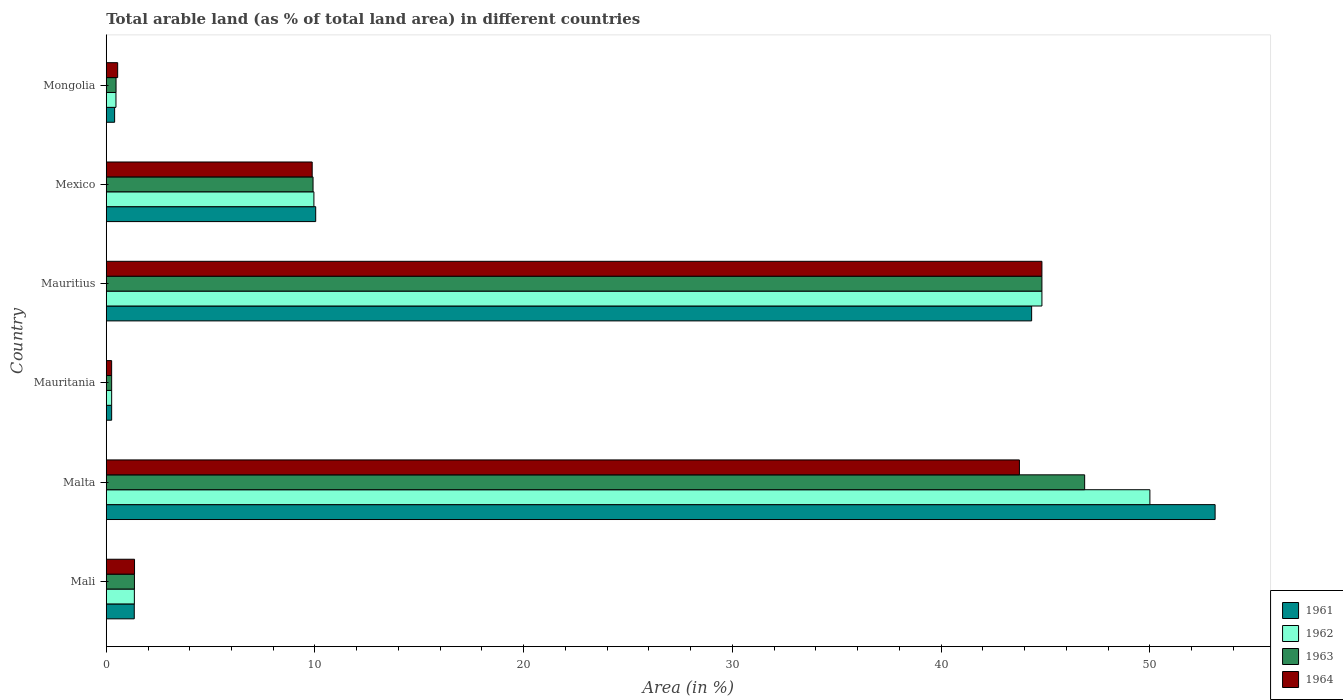How many different coloured bars are there?
Provide a short and direct response. 4. How many groups of bars are there?
Ensure brevity in your answer.  6. Are the number of bars on each tick of the Y-axis equal?
Your answer should be compact. Yes. What is the label of the 4th group of bars from the top?
Ensure brevity in your answer.  Mauritania. In how many cases, is the number of bars for a given country not equal to the number of legend labels?
Ensure brevity in your answer.  0. What is the percentage of arable land in 1963 in Mauritania?
Offer a terse response. 0.26. Across all countries, what is the maximum percentage of arable land in 1964?
Your response must be concise. 44.83. Across all countries, what is the minimum percentage of arable land in 1963?
Your answer should be very brief. 0.26. In which country was the percentage of arable land in 1962 maximum?
Ensure brevity in your answer.  Malta. In which country was the percentage of arable land in 1964 minimum?
Make the answer very short. Mauritania. What is the total percentage of arable land in 1961 in the graph?
Make the answer very short. 109.5. What is the difference between the percentage of arable land in 1962 in Mali and that in Mauritania?
Ensure brevity in your answer.  1.09. What is the difference between the percentage of arable land in 1961 in Mauritius and the percentage of arable land in 1963 in Mexico?
Offer a very short reply. 34.43. What is the average percentage of arable land in 1961 per country?
Keep it short and to the point. 18.25. What is the difference between the percentage of arable land in 1962 and percentage of arable land in 1963 in Mongolia?
Ensure brevity in your answer.  -0. What is the ratio of the percentage of arable land in 1964 in Mauritania to that in Mexico?
Provide a short and direct response. 0.03. Is the percentage of arable land in 1964 in Mali less than that in Mauritania?
Offer a very short reply. No. Is the difference between the percentage of arable land in 1962 in Malta and Mexico greater than the difference between the percentage of arable land in 1963 in Malta and Mexico?
Provide a short and direct response. Yes. What is the difference between the highest and the second highest percentage of arable land in 1964?
Your answer should be very brief. 1.08. What is the difference between the highest and the lowest percentage of arable land in 1964?
Provide a short and direct response. 44.57. Is it the case that in every country, the sum of the percentage of arable land in 1962 and percentage of arable land in 1961 is greater than the sum of percentage of arable land in 1963 and percentage of arable land in 1964?
Keep it short and to the point. No. What does the 1st bar from the top in Mauritania represents?
Your response must be concise. 1964. How many countries are there in the graph?
Provide a succinct answer. 6. What is the difference between two consecutive major ticks on the X-axis?
Ensure brevity in your answer.  10. Are the values on the major ticks of X-axis written in scientific E-notation?
Your answer should be compact. No. Does the graph contain any zero values?
Offer a very short reply. No. Does the graph contain grids?
Keep it short and to the point. No. How many legend labels are there?
Ensure brevity in your answer.  4. How are the legend labels stacked?
Offer a terse response. Vertical. What is the title of the graph?
Give a very brief answer. Total arable land (as % of total land area) in different countries. What is the label or title of the X-axis?
Your response must be concise. Area (in %). What is the label or title of the Y-axis?
Give a very brief answer. Country. What is the Area (in %) of 1961 in Mali?
Your answer should be very brief. 1.34. What is the Area (in %) of 1962 in Mali?
Your response must be concise. 1.35. What is the Area (in %) of 1963 in Mali?
Make the answer very short. 1.35. What is the Area (in %) of 1964 in Mali?
Give a very brief answer. 1.35. What is the Area (in %) of 1961 in Malta?
Keep it short and to the point. 53.12. What is the Area (in %) of 1963 in Malta?
Offer a very short reply. 46.88. What is the Area (in %) of 1964 in Malta?
Keep it short and to the point. 43.75. What is the Area (in %) in 1961 in Mauritania?
Offer a terse response. 0.26. What is the Area (in %) in 1962 in Mauritania?
Make the answer very short. 0.26. What is the Area (in %) in 1963 in Mauritania?
Your answer should be compact. 0.26. What is the Area (in %) of 1964 in Mauritania?
Offer a very short reply. 0.26. What is the Area (in %) of 1961 in Mauritius?
Offer a terse response. 44.33. What is the Area (in %) of 1962 in Mauritius?
Provide a short and direct response. 44.83. What is the Area (in %) of 1963 in Mauritius?
Ensure brevity in your answer.  44.83. What is the Area (in %) in 1964 in Mauritius?
Keep it short and to the point. 44.83. What is the Area (in %) of 1961 in Mexico?
Your answer should be compact. 10.03. What is the Area (in %) of 1962 in Mexico?
Your answer should be compact. 9.95. What is the Area (in %) in 1963 in Mexico?
Offer a terse response. 9.91. What is the Area (in %) in 1964 in Mexico?
Provide a succinct answer. 9.87. What is the Area (in %) in 1961 in Mongolia?
Keep it short and to the point. 0.4. What is the Area (in %) in 1962 in Mongolia?
Provide a succinct answer. 0.47. What is the Area (in %) of 1963 in Mongolia?
Make the answer very short. 0.47. What is the Area (in %) in 1964 in Mongolia?
Your response must be concise. 0.55. Across all countries, what is the maximum Area (in %) in 1961?
Ensure brevity in your answer.  53.12. Across all countries, what is the maximum Area (in %) of 1962?
Your answer should be compact. 50. Across all countries, what is the maximum Area (in %) in 1963?
Provide a succinct answer. 46.88. Across all countries, what is the maximum Area (in %) of 1964?
Ensure brevity in your answer.  44.83. Across all countries, what is the minimum Area (in %) of 1961?
Make the answer very short. 0.26. Across all countries, what is the minimum Area (in %) in 1962?
Give a very brief answer. 0.26. Across all countries, what is the minimum Area (in %) in 1963?
Provide a succinct answer. 0.26. Across all countries, what is the minimum Area (in %) in 1964?
Offer a terse response. 0.26. What is the total Area (in %) in 1961 in the graph?
Give a very brief answer. 109.5. What is the total Area (in %) in 1962 in the graph?
Ensure brevity in your answer.  106.85. What is the total Area (in %) in 1963 in the graph?
Provide a short and direct response. 103.69. What is the total Area (in %) in 1964 in the graph?
Provide a short and direct response. 100.6. What is the difference between the Area (in %) of 1961 in Mali and that in Malta?
Provide a short and direct response. -51.78. What is the difference between the Area (in %) of 1962 in Mali and that in Malta?
Provide a short and direct response. -48.65. What is the difference between the Area (in %) of 1963 in Mali and that in Malta?
Offer a terse response. -45.52. What is the difference between the Area (in %) in 1964 in Mali and that in Malta?
Your answer should be very brief. -42.4. What is the difference between the Area (in %) in 1961 in Mali and that in Mauritania?
Give a very brief answer. 1.08. What is the difference between the Area (in %) in 1962 in Mali and that in Mauritania?
Your response must be concise. 1.09. What is the difference between the Area (in %) of 1963 in Mali and that in Mauritania?
Give a very brief answer. 1.09. What is the difference between the Area (in %) of 1964 in Mali and that in Mauritania?
Ensure brevity in your answer.  1.1. What is the difference between the Area (in %) of 1961 in Mali and that in Mauritius?
Keep it short and to the point. -42.99. What is the difference between the Area (in %) in 1962 in Mali and that in Mauritius?
Make the answer very short. -43.48. What is the difference between the Area (in %) of 1963 in Mali and that in Mauritius?
Your response must be concise. -43.48. What is the difference between the Area (in %) in 1964 in Mali and that in Mauritius?
Your answer should be very brief. -43.47. What is the difference between the Area (in %) of 1961 in Mali and that in Mexico?
Ensure brevity in your answer.  -8.69. What is the difference between the Area (in %) in 1962 in Mali and that in Mexico?
Keep it short and to the point. -8.6. What is the difference between the Area (in %) of 1963 in Mali and that in Mexico?
Your answer should be very brief. -8.56. What is the difference between the Area (in %) in 1964 in Mali and that in Mexico?
Provide a short and direct response. -8.51. What is the difference between the Area (in %) of 1961 in Mali and that in Mongolia?
Your answer should be very brief. 0.94. What is the difference between the Area (in %) in 1962 in Mali and that in Mongolia?
Your answer should be compact. 0.88. What is the difference between the Area (in %) of 1963 in Mali and that in Mongolia?
Give a very brief answer. 0.88. What is the difference between the Area (in %) of 1964 in Mali and that in Mongolia?
Ensure brevity in your answer.  0.81. What is the difference between the Area (in %) of 1961 in Malta and that in Mauritania?
Offer a very short reply. 52.87. What is the difference between the Area (in %) of 1962 in Malta and that in Mauritania?
Your answer should be compact. 49.74. What is the difference between the Area (in %) of 1963 in Malta and that in Mauritania?
Your answer should be very brief. 46.62. What is the difference between the Area (in %) of 1964 in Malta and that in Mauritania?
Your answer should be very brief. 43.49. What is the difference between the Area (in %) in 1961 in Malta and that in Mauritius?
Make the answer very short. 8.79. What is the difference between the Area (in %) of 1962 in Malta and that in Mauritius?
Your answer should be very brief. 5.17. What is the difference between the Area (in %) of 1963 in Malta and that in Mauritius?
Ensure brevity in your answer.  2.05. What is the difference between the Area (in %) in 1964 in Malta and that in Mauritius?
Give a very brief answer. -1.08. What is the difference between the Area (in %) in 1961 in Malta and that in Mexico?
Offer a very short reply. 43.09. What is the difference between the Area (in %) of 1962 in Malta and that in Mexico?
Provide a short and direct response. 40.05. What is the difference between the Area (in %) in 1963 in Malta and that in Mexico?
Make the answer very short. 36.97. What is the difference between the Area (in %) of 1964 in Malta and that in Mexico?
Your answer should be compact. 33.88. What is the difference between the Area (in %) of 1961 in Malta and that in Mongolia?
Ensure brevity in your answer.  52.72. What is the difference between the Area (in %) of 1962 in Malta and that in Mongolia?
Provide a short and direct response. 49.53. What is the difference between the Area (in %) in 1963 in Malta and that in Mongolia?
Make the answer very short. 46.41. What is the difference between the Area (in %) of 1964 in Malta and that in Mongolia?
Provide a succinct answer. 43.2. What is the difference between the Area (in %) in 1961 in Mauritania and that in Mauritius?
Your answer should be very brief. -44.08. What is the difference between the Area (in %) of 1962 in Mauritania and that in Mauritius?
Your answer should be very brief. -44.57. What is the difference between the Area (in %) of 1963 in Mauritania and that in Mauritius?
Your response must be concise. -44.57. What is the difference between the Area (in %) of 1964 in Mauritania and that in Mauritius?
Provide a succinct answer. -44.57. What is the difference between the Area (in %) of 1961 in Mauritania and that in Mexico?
Your answer should be very brief. -9.78. What is the difference between the Area (in %) of 1962 in Mauritania and that in Mexico?
Provide a succinct answer. -9.69. What is the difference between the Area (in %) in 1963 in Mauritania and that in Mexico?
Ensure brevity in your answer.  -9.65. What is the difference between the Area (in %) in 1964 in Mauritania and that in Mexico?
Keep it short and to the point. -9.61. What is the difference between the Area (in %) of 1961 in Mauritania and that in Mongolia?
Offer a terse response. -0.14. What is the difference between the Area (in %) in 1962 in Mauritania and that in Mongolia?
Provide a short and direct response. -0.21. What is the difference between the Area (in %) in 1963 in Mauritania and that in Mongolia?
Your response must be concise. -0.21. What is the difference between the Area (in %) of 1964 in Mauritania and that in Mongolia?
Ensure brevity in your answer.  -0.29. What is the difference between the Area (in %) in 1961 in Mauritius and that in Mexico?
Give a very brief answer. 34.3. What is the difference between the Area (in %) in 1962 in Mauritius and that in Mexico?
Your answer should be compact. 34.88. What is the difference between the Area (in %) in 1963 in Mauritius and that in Mexico?
Your answer should be very brief. 34.92. What is the difference between the Area (in %) in 1964 in Mauritius and that in Mexico?
Offer a terse response. 34.96. What is the difference between the Area (in %) of 1961 in Mauritius and that in Mongolia?
Your response must be concise. 43.93. What is the difference between the Area (in %) in 1962 in Mauritius and that in Mongolia?
Make the answer very short. 44.36. What is the difference between the Area (in %) of 1963 in Mauritius and that in Mongolia?
Offer a terse response. 44.36. What is the difference between the Area (in %) in 1964 in Mauritius and that in Mongolia?
Provide a succinct answer. 44.28. What is the difference between the Area (in %) of 1961 in Mexico and that in Mongolia?
Your answer should be very brief. 9.63. What is the difference between the Area (in %) of 1962 in Mexico and that in Mongolia?
Provide a succinct answer. 9.48. What is the difference between the Area (in %) in 1963 in Mexico and that in Mongolia?
Offer a very short reply. 9.44. What is the difference between the Area (in %) of 1964 in Mexico and that in Mongolia?
Keep it short and to the point. 9.32. What is the difference between the Area (in %) of 1961 in Mali and the Area (in %) of 1962 in Malta?
Offer a very short reply. -48.66. What is the difference between the Area (in %) of 1961 in Mali and the Area (in %) of 1963 in Malta?
Your answer should be compact. -45.53. What is the difference between the Area (in %) of 1961 in Mali and the Area (in %) of 1964 in Malta?
Provide a succinct answer. -42.41. What is the difference between the Area (in %) of 1962 in Mali and the Area (in %) of 1963 in Malta?
Offer a very short reply. -45.53. What is the difference between the Area (in %) of 1962 in Mali and the Area (in %) of 1964 in Malta?
Your answer should be very brief. -42.4. What is the difference between the Area (in %) of 1963 in Mali and the Area (in %) of 1964 in Malta?
Offer a terse response. -42.4. What is the difference between the Area (in %) of 1961 in Mali and the Area (in %) of 1962 in Mauritania?
Provide a succinct answer. 1.08. What is the difference between the Area (in %) of 1961 in Mali and the Area (in %) of 1963 in Mauritania?
Offer a terse response. 1.08. What is the difference between the Area (in %) of 1961 in Mali and the Area (in %) of 1964 in Mauritania?
Give a very brief answer. 1.08. What is the difference between the Area (in %) of 1962 in Mali and the Area (in %) of 1963 in Mauritania?
Offer a terse response. 1.09. What is the difference between the Area (in %) in 1962 in Mali and the Area (in %) in 1964 in Mauritania?
Give a very brief answer. 1.09. What is the difference between the Area (in %) of 1963 in Mali and the Area (in %) of 1964 in Mauritania?
Offer a very short reply. 1.09. What is the difference between the Area (in %) of 1961 in Mali and the Area (in %) of 1962 in Mauritius?
Keep it short and to the point. -43.49. What is the difference between the Area (in %) of 1961 in Mali and the Area (in %) of 1963 in Mauritius?
Offer a terse response. -43.49. What is the difference between the Area (in %) in 1961 in Mali and the Area (in %) in 1964 in Mauritius?
Offer a terse response. -43.49. What is the difference between the Area (in %) of 1962 in Mali and the Area (in %) of 1963 in Mauritius?
Ensure brevity in your answer.  -43.48. What is the difference between the Area (in %) of 1962 in Mali and the Area (in %) of 1964 in Mauritius?
Ensure brevity in your answer.  -43.48. What is the difference between the Area (in %) of 1963 in Mali and the Area (in %) of 1964 in Mauritius?
Your answer should be very brief. -43.48. What is the difference between the Area (in %) of 1961 in Mali and the Area (in %) of 1962 in Mexico?
Your response must be concise. -8.61. What is the difference between the Area (in %) in 1961 in Mali and the Area (in %) in 1963 in Mexico?
Provide a succinct answer. -8.57. What is the difference between the Area (in %) in 1961 in Mali and the Area (in %) in 1964 in Mexico?
Make the answer very short. -8.52. What is the difference between the Area (in %) of 1962 in Mali and the Area (in %) of 1963 in Mexico?
Provide a short and direct response. -8.56. What is the difference between the Area (in %) of 1962 in Mali and the Area (in %) of 1964 in Mexico?
Offer a very short reply. -8.52. What is the difference between the Area (in %) in 1963 in Mali and the Area (in %) in 1964 in Mexico?
Keep it short and to the point. -8.52. What is the difference between the Area (in %) of 1961 in Mali and the Area (in %) of 1962 in Mongolia?
Provide a short and direct response. 0.88. What is the difference between the Area (in %) of 1961 in Mali and the Area (in %) of 1963 in Mongolia?
Ensure brevity in your answer.  0.87. What is the difference between the Area (in %) of 1961 in Mali and the Area (in %) of 1964 in Mongolia?
Offer a terse response. 0.8. What is the difference between the Area (in %) of 1962 in Mali and the Area (in %) of 1963 in Mongolia?
Ensure brevity in your answer.  0.88. What is the difference between the Area (in %) in 1962 in Mali and the Area (in %) in 1964 in Mongolia?
Your response must be concise. 0.8. What is the difference between the Area (in %) of 1963 in Mali and the Area (in %) of 1964 in Mongolia?
Your answer should be compact. 0.8. What is the difference between the Area (in %) in 1961 in Malta and the Area (in %) in 1962 in Mauritania?
Ensure brevity in your answer.  52.87. What is the difference between the Area (in %) in 1961 in Malta and the Area (in %) in 1963 in Mauritania?
Your answer should be compact. 52.87. What is the difference between the Area (in %) in 1961 in Malta and the Area (in %) in 1964 in Mauritania?
Provide a succinct answer. 52.87. What is the difference between the Area (in %) of 1962 in Malta and the Area (in %) of 1963 in Mauritania?
Offer a terse response. 49.74. What is the difference between the Area (in %) of 1962 in Malta and the Area (in %) of 1964 in Mauritania?
Make the answer very short. 49.74. What is the difference between the Area (in %) of 1963 in Malta and the Area (in %) of 1964 in Mauritania?
Ensure brevity in your answer.  46.62. What is the difference between the Area (in %) of 1961 in Malta and the Area (in %) of 1962 in Mauritius?
Provide a short and direct response. 8.3. What is the difference between the Area (in %) of 1961 in Malta and the Area (in %) of 1963 in Mauritius?
Provide a succinct answer. 8.3. What is the difference between the Area (in %) in 1961 in Malta and the Area (in %) in 1964 in Mauritius?
Make the answer very short. 8.3. What is the difference between the Area (in %) of 1962 in Malta and the Area (in %) of 1963 in Mauritius?
Ensure brevity in your answer.  5.17. What is the difference between the Area (in %) in 1962 in Malta and the Area (in %) in 1964 in Mauritius?
Offer a very short reply. 5.17. What is the difference between the Area (in %) of 1963 in Malta and the Area (in %) of 1964 in Mauritius?
Your answer should be very brief. 2.05. What is the difference between the Area (in %) in 1961 in Malta and the Area (in %) in 1962 in Mexico?
Provide a short and direct response. 43.18. What is the difference between the Area (in %) of 1961 in Malta and the Area (in %) of 1963 in Mexico?
Your response must be concise. 43.22. What is the difference between the Area (in %) in 1961 in Malta and the Area (in %) in 1964 in Mexico?
Offer a terse response. 43.26. What is the difference between the Area (in %) in 1962 in Malta and the Area (in %) in 1963 in Mexico?
Offer a terse response. 40.09. What is the difference between the Area (in %) in 1962 in Malta and the Area (in %) in 1964 in Mexico?
Ensure brevity in your answer.  40.13. What is the difference between the Area (in %) of 1963 in Malta and the Area (in %) of 1964 in Mexico?
Your response must be concise. 37.01. What is the difference between the Area (in %) of 1961 in Malta and the Area (in %) of 1962 in Mongolia?
Provide a succinct answer. 52.66. What is the difference between the Area (in %) in 1961 in Malta and the Area (in %) in 1963 in Mongolia?
Your answer should be very brief. 52.66. What is the difference between the Area (in %) of 1961 in Malta and the Area (in %) of 1964 in Mongolia?
Provide a short and direct response. 52.58. What is the difference between the Area (in %) in 1962 in Malta and the Area (in %) in 1963 in Mongolia?
Give a very brief answer. 49.53. What is the difference between the Area (in %) in 1962 in Malta and the Area (in %) in 1964 in Mongolia?
Your answer should be compact. 49.45. What is the difference between the Area (in %) in 1963 in Malta and the Area (in %) in 1964 in Mongolia?
Ensure brevity in your answer.  46.33. What is the difference between the Area (in %) in 1961 in Mauritania and the Area (in %) in 1962 in Mauritius?
Your response must be concise. -44.57. What is the difference between the Area (in %) of 1961 in Mauritania and the Area (in %) of 1963 in Mauritius?
Your response must be concise. -44.57. What is the difference between the Area (in %) of 1961 in Mauritania and the Area (in %) of 1964 in Mauritius?
Provide a short and direct response. -44.57. What is the difference between the Area (in %) in 1962 in Mauritania and the Area (in %) in 1963 in Mauritius?
Keep it short and to the point. -44.57. What is the difference between the Area (in %) in 1962 in Mauritania and the Area (in %) in 1964 in Mauritius?
Provide a short and direct response. -44.57. What is the difference between the Area (in %) of 1963 in Mauritania and the Area (in %) of 1964 in Mauritius?
Offer a very short reply. -44.57. What is the difference between the Area (in %) of 1961 in Mauritania and the Area (in %) of 1962 in Mexico?
Your answer should be very brief. -9.69. What is the difference between the Area (in %) of 1961 in Mauritania and the Area (in %) of 1963 in Mexico?
Your response must be concise. -9.65. What is the difference between the Area (in %) in 1961 in Mauritania and the Area (in %) in 1964 in Mexico?
Your answer should be compact. -9.61. What is the difference between the Area (in %) of 1962 in Mauritania and the Area (in %) of 1963 in Mexico?
Make the answer very short. -9.65. What is the difference between the Area (in %) of 1962 in Mauritania and the Area (in %) of 1964 in Mexico?
Offer a very short reply. -9.61. What is the difference between the Area (in %) of 1963 in Mauritania and the Area (in %) of 1964 in Mexico?
Offer a very short reply. -9.61. What is the difference between the Area (in %) in 1961 in Mauritania and the Area (in %) in 1962 in Mongolia?
Give a very brief answer. -0.21. What is the difference between the Area (in %) in 1961 in Mauritania and the Area (in %) in 1963 in Mongolia?
Ensure brevity in your answer.  -0.21. What is the difference between the Area (in %) in 1961 in Mauritania and the Area (in %) in 1964 in Mongolia?
Give a very brief answer. -0.29. What is the difference between the Area (in %) in 1962 in Mauritania and the Area (in %) in 1963 in Mongolia?
Your answer should be compact. -0.21. What is the difference between the Area (in %) in 1962 in Mauritania and the Area (in %) in 1964 in Mongolia?
Keep it short and to the point. -0.29. What is the difference between the Area (in %) in 1963 in Mauritania and the Area (in %) in 1964 in Mongolia?
Offer a very short reply. -0.29. What is the difference between the Area (in %) of 1961 in Mauritius and the Area (in %) of 1962 in Mexico?
Your answer should be very brief. 34.39. What is the difference between the Area (in %) in 1961 in Mauritius and the Area (in %) in 1963 in Mexico?
Offer a very short reply. 34.43. What is the difference between the Area (in %) in 1961 in Mauritius and the Area (in %) in 1964 in Mexico?
Your answer should be very brief. 34.47. What is the difference between the Area (in %) in 1962 in Mauritius and the Area (in %) in 1963 in Mexico?
Provide a short and direct response. 34.92. What is the difference between the Area (in %) of 1962 in Mauritius and the Area (in %) of 1964 in Mexico?
Offer a terse response. 34.96. What is the difference between the Area (in %) in 1963 in Mauritius and the Area (in %) in 1964 in Mexico?
Provide a short and direct response. 34.96. What is the difference between the Area (in %) of 1961 in Mauritius and the Area (in %) of 1962 in Mongolia?
Ensure brevity in your answer.  43.87. What is the difference between the Area (in %) in 1961 in Mauritius and the Area (in %) in 1963 in Mongolia?
Give a very brief answer. 43.87. What is the difference between the Area (in %) in 1961 in Mauritius and the Area (in %) in 1964 in Mongolia?
Your response must be concise. 43.79. What is the difference between the Area (in %) of 1962 in Mauritius and the Area (in %) of 1963 in Mongolia?
Make the answer very short. 44.36. What is the difference between the Area (in %) in 1962 in Mauritius and the Area (in %) in 1964 in Mongolia?
Provide a short and direct response. 44.28. What is the difference between the Area (in %) in 1963 in Mauritius and the Area (in %) in 1964 in Mongolia?
Your response must be concise. 44.28. What is the difference between the Area (in %) in 1961 in Mexico and the Area (in %) in 1962 in Mongolia?
Make the answer very short. 9.57. What is the difference between the Area (in %) of 1961 in Mexico and the Area (in %) of 1963 in Mongolia?
Your answer should be very brief. 9.57. What is the difference between the Area (in %) in 1961 in Mexico and the Area (in %) in 1964 in Mongolia?
Make the answer very short. 9.49. What is the difference between the Area (in %) of 1962 in Mexico and the Area (in %) of 1963 in Mongolia?
Provide a short and direct response. 9.48. What is the difference between the Area (in %) in 1962 in Mexico and the Area (in %) in 1964 in Mongolia?
Ensure brevity in your answer.  9.4. What is the difference between the Area (in %) in 1963 in Mexico and the Area (in %) in 1964 in Mongolia?
Provide a succinct answer. 9.36. What is the average Area (in %) of 1961 per country?
Provide a short and direct response. 18.25. What is the average Area (in %) in 1962 per country?
Offer a very short reply. 17.81. What is the average Area (in %) in 1963 per country?
Offer a terse response. 17.28. What is the average Area (in %) of 1964 per country?
Keep it short and to the point. 16.77. What is the difference between the Area (in %) of 1961 and Area (in %) of 1962 in Mali?
Offer a terse response. -0. What is the difference between the Area (in %) in 1961 and Area (in %) in 1963 in Mali?
Your answer should be compact. -0.01. What is the difference between the Area (in %) in 1961 and Area (in %) in 1964 in Mali?
Make the answer very short. -0.01. What is the difference between the Area (in %) in 1962 and Area (in %) in 1963 in Mali?
Your answer should be very brief. -0. What is the difference between the Area (in %) of 1962 and Area (in %) of 1964 in Mali?
Your response must be concise. -0.01. What is the difference between the Area (in %) in 1963 and Area (in %) in 1964 in Mali?
Give a very brief answer. -0. What is the difference between the Area (in %) in 1961 and Area (in %) in 1962 in Malta?
Your answer should be compact. 3.12. What is the difference between the Area (in %) of 1961 and Area (in %) of 1963 in Malta?
Your answer should be very brief. 6.25. What is the difference between the Area (in %) of 1961 and Area (in %) of 1964 in Malta?
Give a very brief answer. 9.38. What is the difference between the Area (in %) in 1962 and Area (in %) in 1963 in Malta?
Provide a succinct answer. 3.12. What is the difference between the Area (in %) in 1962 and Area (in %) in 1964 in Malta?
Your response must be concise. 6.25. What is the difference between the Area (in %) of 1963 and Area (in %) of 1964 in Malta?
Keep it short and to the point. 3.12. What is the difference between the Area (in %) of 1961 and Area (in %) of 1962 in Mauritania?
Ensure brevity in your answer.  0. What is the difference between the Area (in %) in 1961 and Area (in %) in 1964 in Mauritania?
Your answer should be compact. 0. What is the difference between the Area (in %) of 1961 and Area (in %) of 1962 in Mauritius?
Your response must be concise. -0.49. What is the difference between the Area (in %) of 1961 and Area (in %) of 1963 in Mauritius?
Your answer should be very brief. -0.49. What is the difference between the Area (in %) of 1961 and Area (in %) of 1964 in Mauritius?
Your answer should be very brief. -0.49. What is the difference between the Area (in %) of 1962 and Area (in %) of 1964 in Mauritius?
Provide a short and direct response. 0. What is the difference between the Area (in %) in 1963 and Area (in %) in 1964 in Mauritius?
Make the answer very short. 0. What is the difference between the Area (in %) of 1961 and Area (in %) of 1962 in Mexico?
Your answer should be very brief. 0.09. What is the difference between the Area (in %) in 1961 and Area (in %) in 1963 in Mexico?
Your answer should be compact. 0.13. What is the difference between the Area (in %) of 1961 and Area (in %) of 1964 in Mexico?
Your response must be concise. 0.17. What is the difference between the Area (in %) of 1962 and Area (in %) of 1963 in Mexico?
Offer a terse response. 0.04. What is the difference between the Area (in %) in 1962 and Area (in %) in 1964 in Mexico?
Make the answer very short. 0.08. What is the difference between the Area (in %) of 1963 and Area (in %) of 1964 in Mexico?
Your answer should be compact. 0.04. What is the difference between the Area (in %) in 1961 and Area (in %) in 1962 in Mongolia?
Offer a very short reply. -0.06. What is the difference between the Area (in %) in 1961 and Area (in %) in 1963 in Mongolia?
Keep it short and to the point. -0.07. What is the difference between the Area (in %) of 1961 and Area (in %) of 1964 in Mongolia?
Offer a terse response. -0.15. What is the difference between the Area (in %) in 1962 and Area (in %) in 1963 in Mongolia?
Keep it short and to the point. -0. What is the difference between the Area (in %) in 1962 and Area (in %) in 1964 in Mongolia?
Your response must be concise. -0.08. What is the difference between the Area (in %) in 1963 and Area (in %) in 1964 in Mongolia?
Provide a succinct answer. -0.08. What is the ratio of the Area (in %) in 1961 in Mali to that in Malta?
Keep it short and to the point. 0.03. What is the ratio of the Area (in %) in 1962 in Mali to that in Malta?
Offer a very short reply. 0.03. What is the ratio of the Area (in %) of 1963 in Mali to that in Malta?
Offer a very short reply. 0.03. What is the ratio of the Area (in %) in 1964 in Mali to that in Malta?
Give a very brief answer. 0.03. What is the ratio of the Area (in %) in 1961 in Mali to that in Mauritania?
Your answer should be compact. 5.18. What is the ratio of the Area (in %) in 1962 in Mali to that in Mauritania?
Offer a very short reply. 5.2. What is the ratio of the Area (in %) of 1963 in Mali to that in Mauritania?
Your answer should be compact. 5.21. What is the ratio of the Area (in %) in 1964 in Mali to that in Mauritania?
Make the answer very short. 5.25. What is the ratio of the Area (in %) of 1961 in Mali to that in Mauritius?
Offer a terse response. 0.03. What is the ratio of the Area (in %) in 1963 in Mali to that in Mauritius?
Offer a terse response. 0.03. What is the ratio of the Area (in %) in 1964 in Mali to that in Mauritius?
Make the answer very short. 0.03. What is the ratio of the Area (in %) in 1961 in Mali to that in Mexico?
Keep it short and to the point. 0.13. What is the ratio of the Area (in %) in 1962 in Mali to that in Mexico?
Keep it short and to the point. 0.14. What is the ratio of the Area (in %) of 1963 in Mali to that in Mexico?
Provide a short and direct response. 0.14. What is the ratio of the Area (in %) of 1964 in Mali to that in Mexico?
Offer a terse response. 0.14. What is the ratio of the Area (in %) in 1961 in Mali to that in Mongolia?
Ensure brevity in your answer.  3.34. What is the ratio of the Area (in %) of 1962 in Mali to that in Mongolia?
Give a very brief answer. 2.89. What is the ratio of the Area (in %) in 1963 in Mali to that in Mongolia?
Keep it short and to the point. 2.88. What is the ratio of the Area (in %) of 1964 in Mali to that in Mongolia?
Offer a very short reply. 2.48. What is the ratio of the Area (in %) of 1961 in Malta to that in Mauritania?
Your answer should be very brief. 205.08. What is the ratio of the Area (in %) of 1962 in Malta to that in Mauritania?
Ensure brevity in your answer.  193.01. What is the ratio of the Area (in %) of 1963 in Malta to that in Mauritania?
Offer a very short reply. 180.95. What is the ratio of the Area (in %) of 1964 in Malta to that in Mauritania?
Keep it short and to the point. 169.52. What is the ratio of the Area (in %) of 1961 in Malta to that in Mauritius?
Provide a succinct answer. 1.2. What is the ratio of the Area (in %) of 1962 in Malta to that in Mauritius?
Offer a very short reply. 1.12. What is the ratio of the Area (in %) in 1963 in Malta to that in Mauritius?
Provide a short and direct response. 1.05. What is the ratio of the Area (in %) in 1964 in Malta to that in Mauritius?
Keep it short and to the point. 0.98. What is the ratio of the Area (in %) in 1961 in Malta to that in Mexico?
Provide a short and direct response. 5.29. What is the ratio of the Area (in %) in 1962 in Malta to that in Mexico?
Provide a short and direct response. 5.03. What is the ratio of the Area (in %) of 1963 in Malta to that in Mexico?
Your answer should be compact. 4.73. What is the ratio of the Area (in %) of 1964 in Malta to that in Mexico?
Your answer should be very brief. 4.43. What is the ratio of the Area (in %) of 1961 in Malta to that in Mongolia?
Ensure brevity in your answer.  132.26. What is the ratio of the Area (in %) of 1962 in Malta to that in Mongolia?
Your answer should be very brief. 107.29. What is the ratio of the Area (in %) of 1963 in Malta to that in Mongolia?
Give a very brief answer. 99.89. What is the ratio of the Area (in %) in 1964 in Malta to that in Mongolia?
Provide a succinct answer. 79.96. What is the ratio of the Area (in %) in 1961 in Mauritania to that in Mauritius?
Your answer should be compact. 0.01. What is the ratio of the Area (in %) in 1962 in Mauritania to that in Mauritius?
Provide a short and direct response. 0.01. What is the ratio of the Area (in %) in 1963 in Mauritania to that in Mauritius?
Offer a terse response. 0.01. What is the ratio of the Area (in %) in 1964 in Mauritania to that in Mauritius?
Keep it short and to the point. 0.01. What is the ratio of the Area (in %) in 1961 in Mauritania to that in Mexico?
Make the answer very short. 0.03. What is the ratio of the Area (in %) in 1962 in Mauritania to that in Mexico?
Give a very brief answer. 0.03. What is the ratio of the Area (in %) of 1963 in Mauritania to that in Mexico?
Provide a succinct answer. 0.03. What is the ratio of the Area (in %) in 1964 in Mauritania to that in Mexico?
Offer a terse response. 0.03. What is the ratio of the Area (in %) in 1961 in Mauritania to that in Mongolia?
Keep it short and to the point. 0.64. What is the ratio of the Area (in %) in 1962 in Mauritania to that in Mongolia?
Make the answer very short. 0.56. What is the ratio of the Area (in %) in 1963 in Mauritania to that in Mongolia?
Your answer should be very brief. 0.55. What is the ratio of the Area (in %) of 1964 in Mauritania to that in Mongolia?
Keep it short and to the point. 0.47. What is the ratio of the Area (in %) of 1961 in Mauritius to that in Mexico?
Ensure brevity in your answer.  4.42. What is the ratio of the Area (in %) in 1962 in Mauritius to that in Mexico?
Provide a short and direct response. 4.51. What is the ratio of the Area (in %) of 1963 in Mauritius to that in Mexico?
Give a very brief answer. 4.52. What is the ratio of the Area (in %) of 1964 in Mauritius to that in Mexico?
Keep it short and to the point. 4.54. What is the ratio of the Area (in %) in 1961 in Mauritius to that in Mongolia?
Your response must be concise. 110.38. What is the ratio of the Area (in %) of 1962 in Mauritius to that in Mongolia?
Ensure brevity in your answer.  96.19. What is the ratio of the Area (in %) in 1963 in Mauritius to that in Mongolia?
Offer a very short reply. 95.53. What is the ratio of the Area (in %) of 1964 in Mauritius to that in Mongolia?
Offer a very short reply. 81.93. What is the ratio of the Area (in %) in 1961 in Mexico to that in Mongolia?
Offer a terse response. 24.98. What is the ratio of the Area (in %) in 1962 in Mexico to that in Mongolia?
Offer a very short reply. 21.35. What is the ratio of the Area (in %) of 1963 in Mexico to that in Mongolia?
Give a very brief answer. 21.11. What is the ratio of the Area (in %) of 1964 in Mexico to that in Mongolia?
Give a very brief answer. 18.03. What is the difference between the highest and the second highest Area (in %) of 1961?
Your answer should be very brief. 8.79. What is the difference between the highest and the second highest Area (in %) of 1962?
Offer a terse response. 5.17. What is the difference between the highest and the second highest Area (in %) of 1963?
Offer a very short reply. 2.05. What is the difference between the highest and the second highest Area (in %) in 1964?
Your answer should be compact. 1.08. What is the difference between the highest and the lowest Area (in %) of 1961?
Offer a very short reply. 52.87. What is the difference between the highest and the lowest Area (in %) in 1962?
Provide a succinct answer. 49.74. What is the difference between the highest and the lowest Area (in %) of 1963?
Provide a succinct answer. 46.62. What is the difference between the highest and the lowest Area (in %) in 1964?
Offer a terse response. 44.57. 